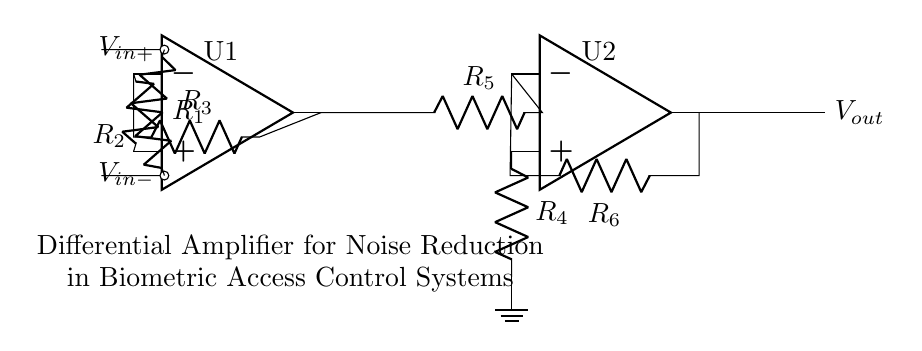What is the purpose of this circuit? The circuit is designed as a differential amplifier aimed at minimizing noise in biometric access control systems. This is indicated by the label present in the diagram that specifically states its application.
Answer: Noise reduction What type of op-amps are used here? The diagram shows two operational amplifiers, which are labeled as U1 and U2, indicating their function within the differential amplifier configuration.
Answer: Two How many resistors are present in the circuit? The circuit includes six resistors, as counted from the labels R1, R2, R3, R4, R5, and R6, which are part of the differential amplifier setup.
Answer: Six What is the role of resistors R1 and R2? Resistors R1 and R2 serve as input resistors connecting the input signals to the operational amplifier. They help determine the gain of the amplifier, allowing for differential input processing.
Answer: Input resistors What connection type is used for the output of the second op-amp? The output from U2 (the second op-amp) is shown to have a direct connection leading to the output point labeled as Vout, indicating a simple voltage output configuration without additional components.
Answer: Direct connection What is the function of resistor R5 in this circuit? Resistor R5 acts as a feedback resistor connected between the output of the first op-amp and the inverting input of the second op-amp, playing a crucial role in the gain control of the overall circuit.
Answer: Feedback resistor How do the inputs V_in+ and V_in- affect the output? The differential inputs, V_in+ and V_in-, influence the output V_out based on their voltage difference, with the circuit amplifying this difference while rejecting any common-mode noise present in both inputs.
Answer: Differential voltage 